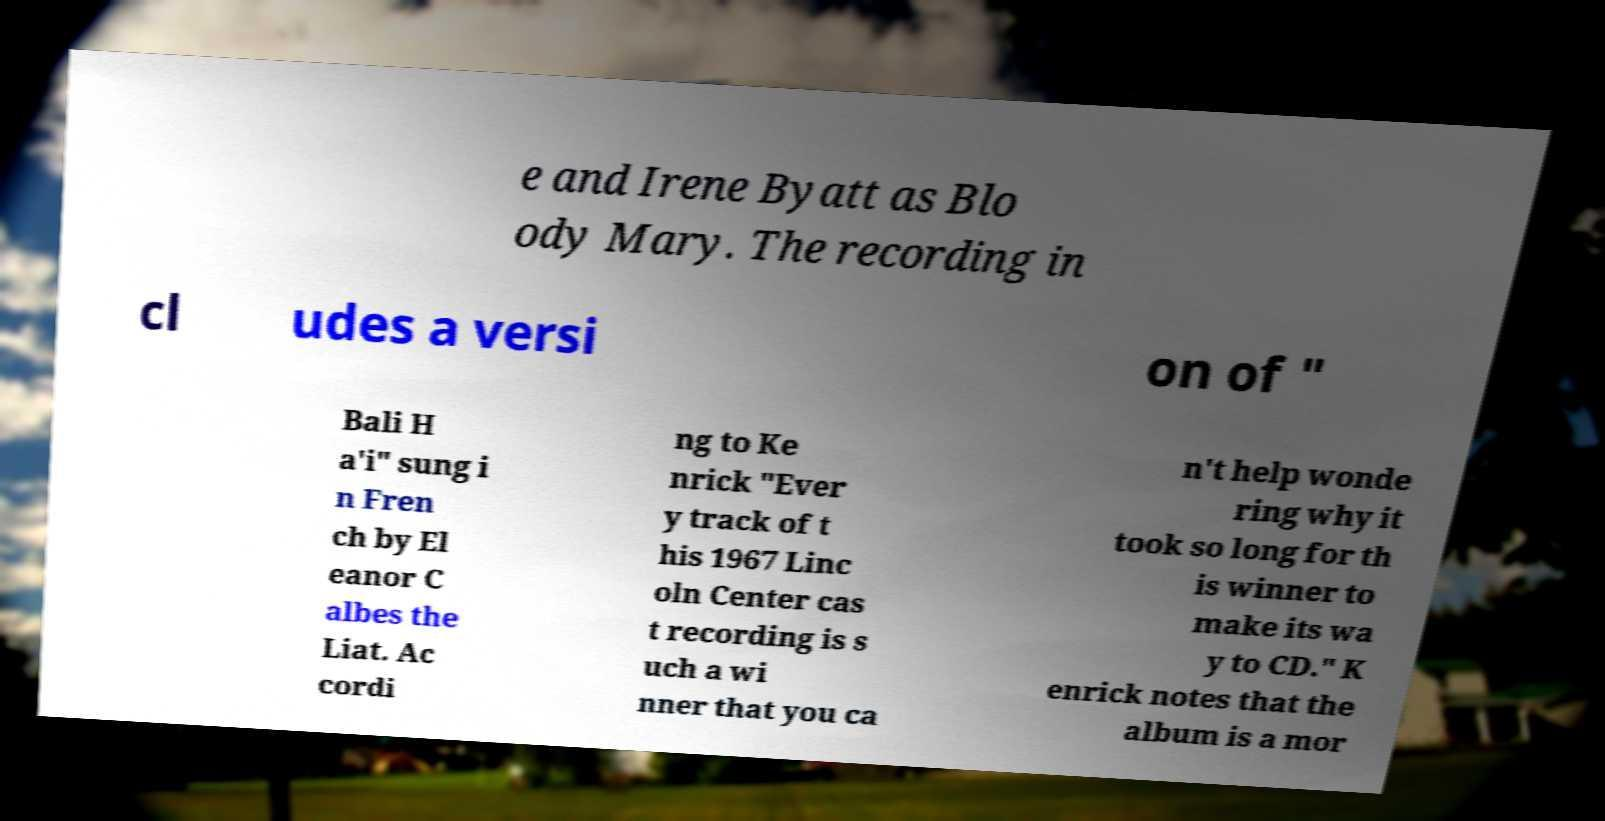There's text embedded in this image that I need extracted. Can you transcribe it verbatim? e and Irene Byatt as Blo ody Mary. The recording in cl udes a versi on of " Bali H a'i" sung i n Fren ch by El eanor C albes the Liat. Ac cordi ng to Ke nrick "Ever y track of t his 1967 Linc oln Center cas t recording is s uch a wi nner that you ca n't help wonde ring why it took so long for th is winner to make its wa y to CD." K enrick notes that the album is a mor 